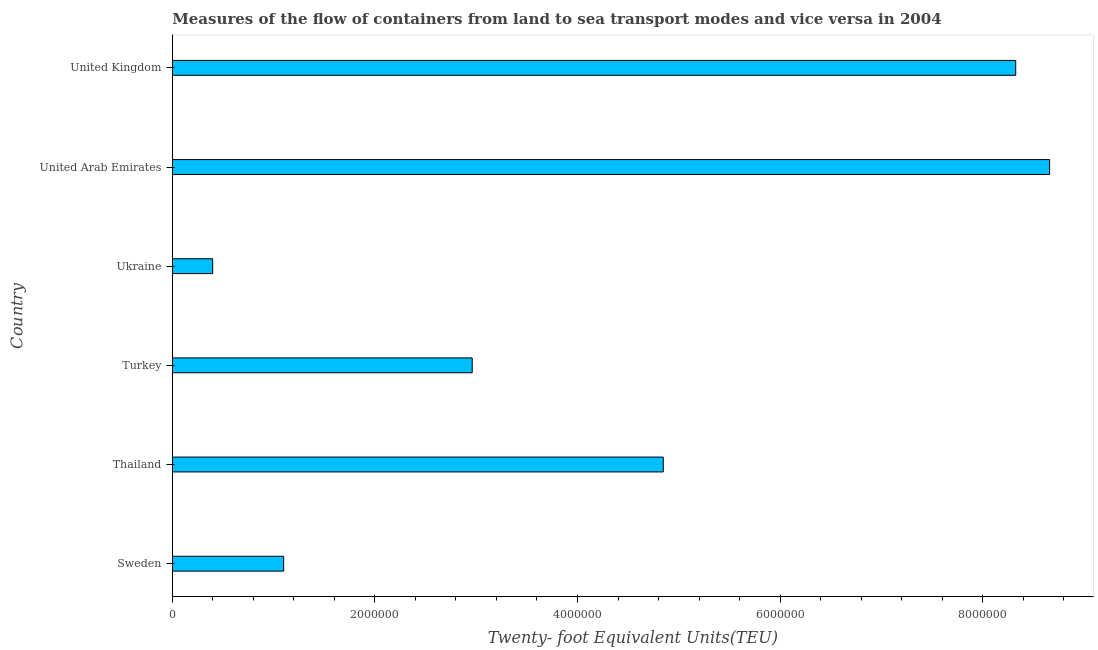Does the graph contain grids?
Your answer should be compact. No. What is the title of the graph?
Give a very brief answer. Measures of the flow of containers from land to sea transport modes and vice versa in 2004. What is the label or title of the X-axis?
Your response must be concise. Twenty- foot Equivalent Units(TEU). What is the container port traffic in United Kingdom?
Provide a short and direct response. 8.33e+06. Across all countries, what is the maximum container port traffic?
Make the answer very short. 8.66e+06. Across all countries, what is the minimum container port traffic?
Provide a succinct answer. 3.98e+05. In which country was the container port traffic maximum?
Offer a terse response. United Arab Emirates. In which country was the container port traffic minimum?
Make the answer very short. Ukraine. What is the sum of the container port traffic?
Your answer should be compact. 2.63e+07. What is the difference between the container port traffic in Sweden and United Kingdom?
Provide a short and direct response. -7.23e+06. What is the average container port traffic per country?
Give a very brief answer. 4.38e+06. What is the median container port traffic?
Provide a short and direct response. 3.90e+06. In how many countries, is the container port traffic greater than 2400000 TEU?
Provide a short and direct response. 4. What is the ratio of the container port traffic in Thailand to that in Ukraine?
Your answer should be compact. 12.18. Is the container port traffic in United Arab Emirates less than that in United Kingdom?
Offer a very short reply. No. What is the difference between the highest and the second highest container port traffic?
Give a very brief answer. 3.35e+05. What is the difference between the highest and the lowest container port traffic?
Offer a very short reply. 8.26e+06. What is the Twenty- foot Equivalent Units(TEU) of Sweden?
Provide a short and direct response. 1.10e+06. What is the Twenty- foot Equivalent Units(TEU) of Thailand?
Your response must be concise. 4.85e+06. What is the Twenty- foot Equivalent Units(TEU) in Turkey?
Keep it short and to the point. 2.96e+06. What is the Twenty- foot Equivalent Units(TEU) of Ukraine?
Your answer should be very brief. 3.98e+05. What is the Twenty- foot Equivalent Units(TEU) of United Arab Emirates?
Offer a very short reply. 8.66e+06. What is the Twenty- foot Equivalent Units(TEU) of United Kingdom?
Your answer should be very brief. 8.33e+06. What is the difference between the Twenty- foot Equivalent Units(TEU) in Sweden and Thailand?
Your answer should be very brief. -3.75e+06. What is the difference between the Twenty- foot Equivalent Units(TEU) in Sweden and Turkey?
Offer a terse response. -1.86e+06. What is the difference between the Twenty- foot Equivalent Units(TEU) in Sweden and Ukraine?
Your answer should be very brief. 7.01e+05. What is the difference between the Twenty- foot Equivalent Units(TEU) in Sweden and United Arab Emirates?
Ensure brevity in your answer.  -7.56e+06. What is the difference between the Twenty- foot Equivalent Units(TEU) in Sweden and United Kingdom?
Your answer should be compact. -7.23e+06. What is the difference between the Twenty- foot Equivalent Units(TEU) in Thailand and Turkey?
Provide a succinct answer. 1.89e+06. What is the difference between the Twenty- foot Equivalent Units(TEU) in Thailand and Ukraine?
Make the answer very short. 4.45e+06. What is the difference between the Twenty- foot Equivalent Units(TEU) in Thailand and United Arab Emirates?
Give a very brief answer. -3.81e+06. What is the difference between the Twenty- foot Equivalent Units(TEU) in Thailand and United Kingdom?
Keep it short and to the point. -3.48e+06. What is the difference between the Twenty- foot Equivalent Units(TEU) in Turkey and Ukraine?
Give a very brief answer. 2.56e+06. What is the difference between the Twenty- foot Equivalent Units(TEU) in Turkey and United Arab Emirates?
Your response must be concise. -5.70e+06. What is the difference between the Twenty- foot Equivalent Units(TEU) in Turkey and United Kingdom?
Keep it short and to the point. -5.37e+06. What is the difference between the Twenty- foot Equivalent Units(TEU) in Ukraine and United Arab Emirates?
Provide a short and direct response. -8.26e+06. What is the difference between the Twenty- foot Equivalent Units(TEU) in Ukraine and United Kingdom?
Your answer should be compact. -7.93e+06. What is the difference between the Twenty- foot Equivalent Units(TEU) in United Arab Emirates and United Kingdom?
Ensure brevity in your answer.  3.35e+05. What is the ratio of the Twenty- foot Equivalent Units(TEU) in Sweden to that in Thailand?
Give a very brief answer. 0.23. What is the ratio of the Twenty- foot Equivalent Units(TEU) in Sweden to that in Turkey?
Provide a short and direct response. 0.37. What is the ratio of the Twenty- foot Equivalent Units(TEU) in Sweden to that in Ukraine?
Provide a short and direct response. 2.76. What is the ratio of the Twenty- foot Equivalent Units(TEU) in Sweden to that in United Arab Emirates?
Your answer should be very brief. 0.13. What is the ratio of the Twenty- foot Equivalent Units(TEU) in Sweden to that in United Kingdom?
Your answer should be compact. 0.13. What is the ratio of the Twenty- foot Equivalent Units(TEU) in Thailand to that in Turkey?
Offer a terse response. 1.64. What is the ratio of the Twenty- foot Equivalent Units(TEU) in Thailand to that in Ukraine?
Ensure brevity in your answer.  12.18. What is the ratio of the Twenty- foot Equivalent Units(TEU) in Thailand to that in United Arab Emirates?
Offer a very short reply. 0.56. What is the ratio of the Twenty- foot Equivalent Units(TEU) in Thailand to that in United Kingdom?
Offer a terse response. 0.58. What is the ratio of the Twenty- foot Equivalent Units(TEU) in Turkey to that in Ukraine?
Your answer should be compact. 7.44. What is the ratio of the Twenty- foot Equivalent Units(TEU) in Turkey to that in United Arab Emirates?
Ensure brevity in your answer.  0.34. What is the ratio of the Twenty- foot Equivalent Units(TEU) in Turkey to that in United Kingdom?
Give a very brief answer. 0.36. What is the ratio of the Twenty- foot Equivalent Units(TEU) in Ukraine to that in United Arab Emirates?
Your answer should be compact. 0.05. What is the ratio of the Twenty- foot Equivalent Units(TEU) in Ukraine to that in United Kingdom?
Keep it short and to the point. 0.05. What is the ratio of the Twenty- foot Equivalent Units(TEU) in United Arab Emirates to that in United Kingdom?
Offer a very short reply. 1.04. 